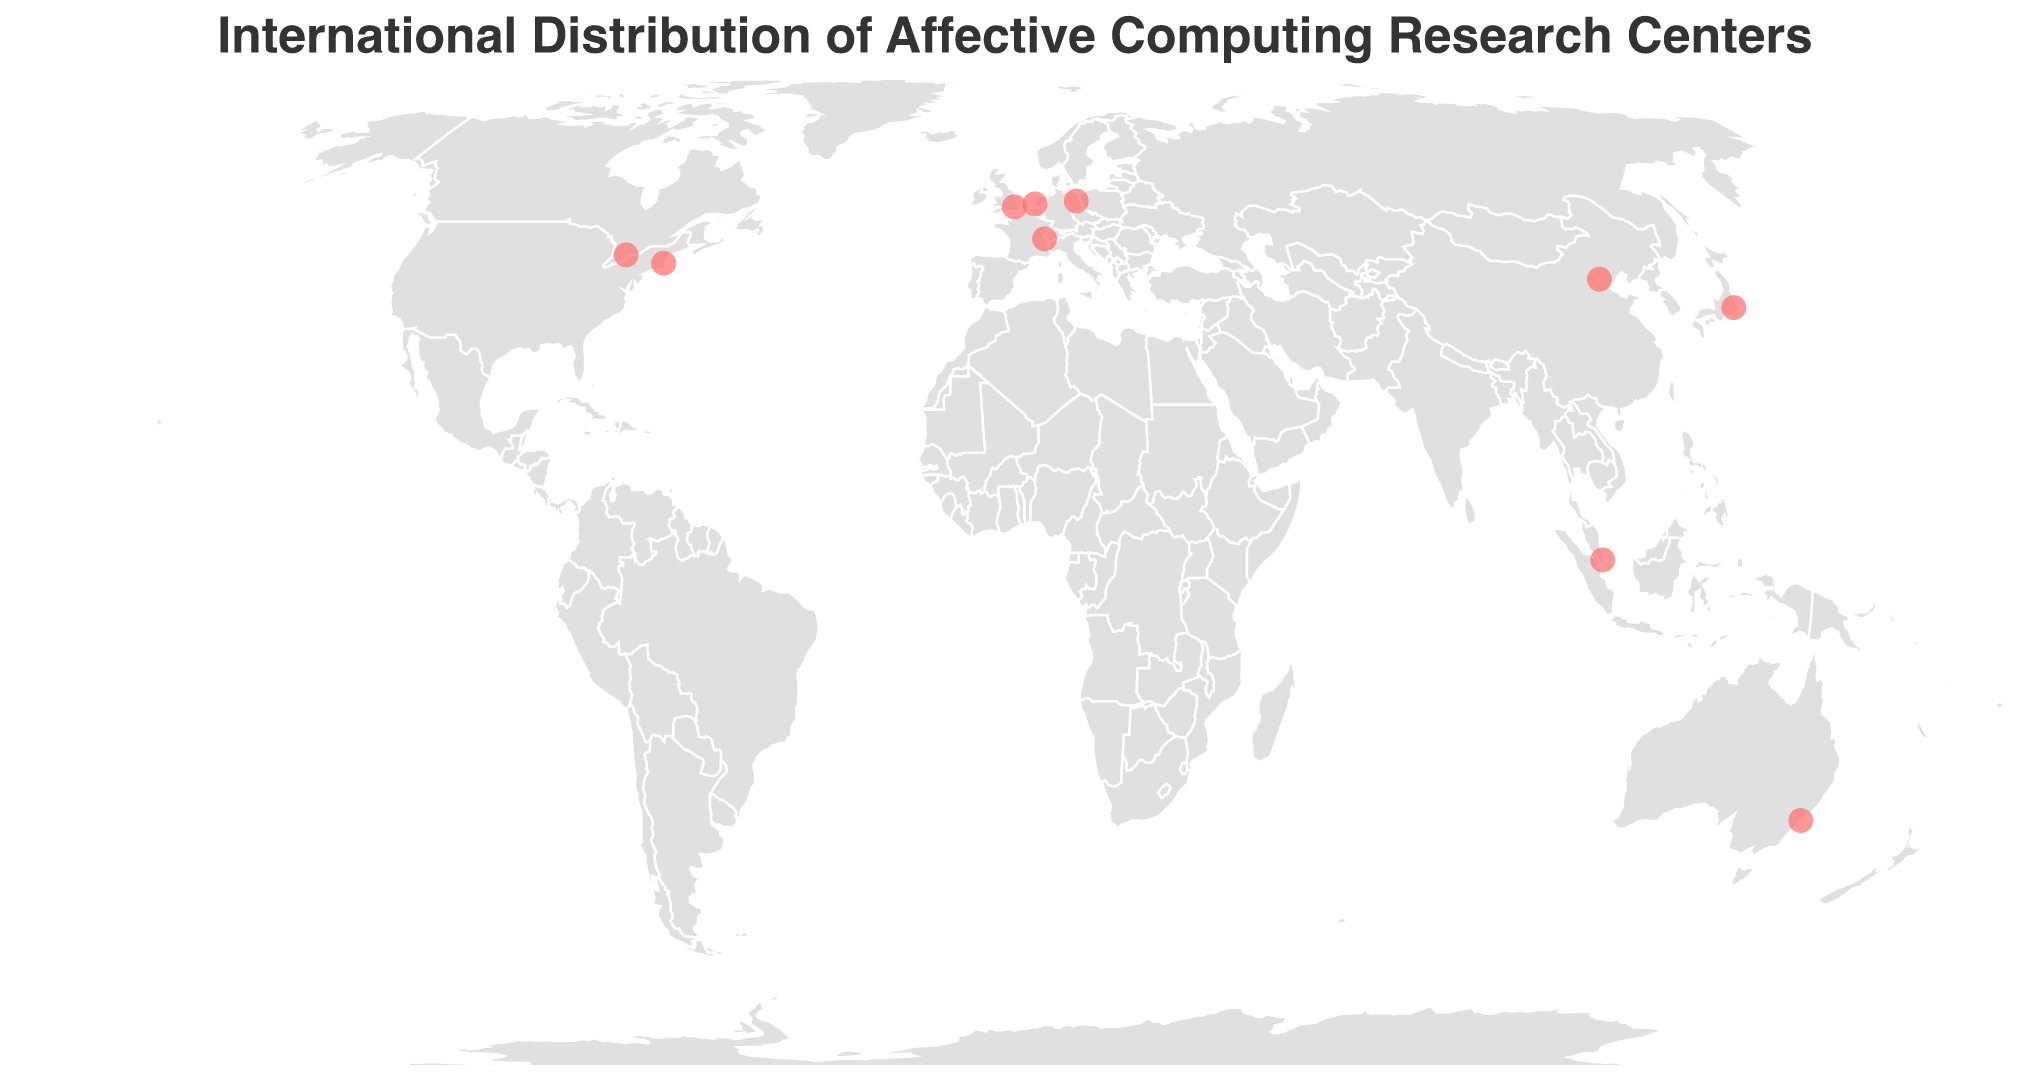What is the title of the figure? The title is typically found at the top of the figure, providing a summary of what the visual represents. Here, it states, "International Distribution of Affective Computing Research Centers"
Answer: International Distribution of Affective Computing Research Centers How many research centers are shown on the map? By counting the number of data points (circles) displayed on the map, we can determine the number of research centers. Each circle corresponds to a research center
Answer: 10 Which two cities have the research centers closest to each other in Europe based on the map? By visually inspecting the map, and focusing on Europe, we see that London (UK) and Berlin (Germany) have the closest proximity among the research centers shown in Europe
Answer: London and Berlin What is the specialization of the research center located in Sydney? Hovering over or inspecting the circle situated at the coordinates for Sydney (Australia) reveals the tooltip, showing the specialization of the research center there
Answer: Affective Computing in Virtual Reality How many continents are represented by the research centers on the map? By examining the geographic distribution of the data points on the map, we find that the research centers are located in North America, Europe, Asia, Australia, and (implicitly) Africa through the inclusion of the Mediterranean regions
Answer: 5 Compare the number of research centers between North America and Asia. Which has more? By counting the number of data points in North America (USA, Canada) and Asia (Japan, China, Singapore), we can conclude that both continents have an equal number of research centers
Answer: They are equal What is the research specialization for the center located at the highest latitude? The circle located at the highest latitude on the map corresponds to the research center in Berlin, Germany, which has the specialization "Affective Human-Computer Interaction" based on its tooltip
Answer: Affective Human-Computer Interaction Which country hosts the research center specializing in Deep Learning for Emotion Recognition? By checking the tooltips for each circle, we find that the Vector Institute for Artificial Intelligence in Toronto, Canada, specializes in Deep Learning for Emotion Recognition
Answer: Canada How many research centers specialize in some form of emotion recognition? To answer this, identify research centers with specializations related to emotion recognition, including "Multimodal Affective Computing," "Emotion Recognition in Robotics," "Affective Natural Language Processing," and "Deep Learning for Emotion Recognition." Four centers have these specializations
Answer: 4 In which continent is the Swiss Center for Affective Sciences located? By locating Switzerland on the map (in Europe) and recognizing Geneva as its city, we can conclude that the Swiss Center for Affective Sciences is in Europe
Answer: Europe 